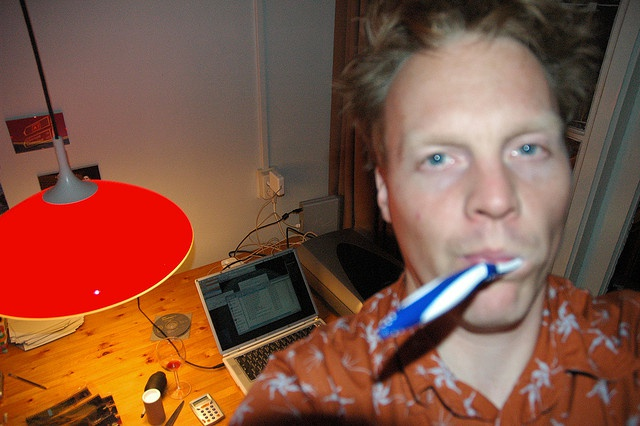Describe the objects in this image and their specific colors. I can see people in black, darkgray, maroon, and tan tones, laptop in black and gray tones, toothbrush in black, white, blue, and lightblue tones, wine glass in black, red, orange, and brown tones, and cup in black, maroon, beige, and brown tones in this image. 